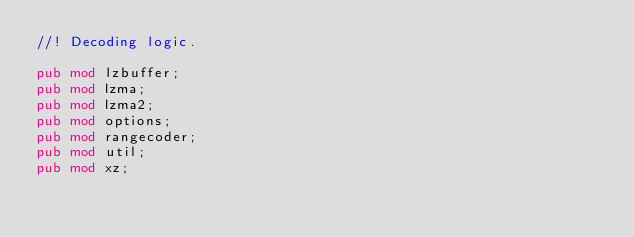<code> <loc_0><loc_0><loc_500><loc_500><_Rust_>//! Decoding logic.

pub mod lzbuffer;
pub mod lzma;
pub mod lzma2;
pub mod options;
pub mod rangecoder;
pub mod util;
pub mod xz;
</code> 